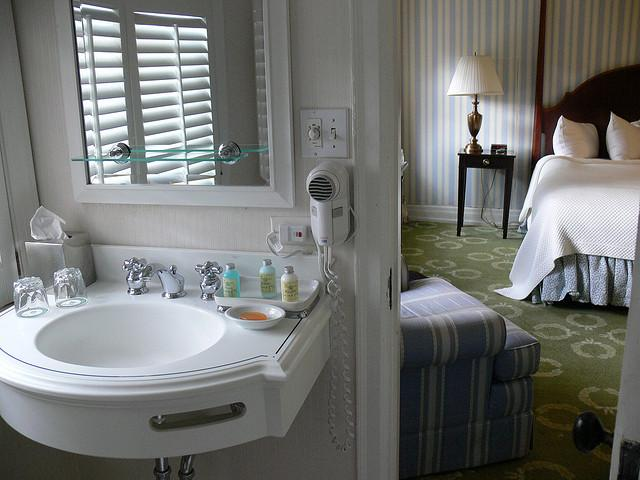What is the corded device called that's on the wall?

Choices:
A) hair dryer
B) mixer
C) tv
D) wall phone hair dryer 